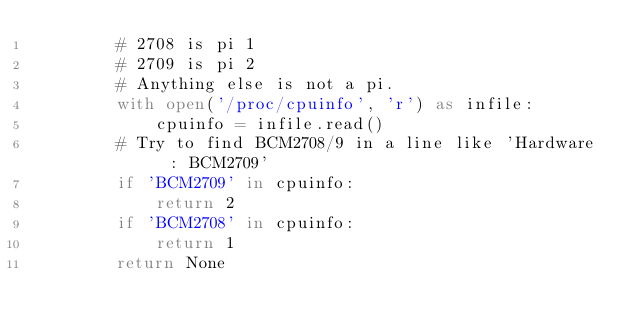<code> <loc_0><loc_0><loc_500><loc_500><_Python_>        # 2708 is pi 1
        # 2709 is pi 2
        # Anything else is not a pi.
        with open('/proc/cpuinfo', 'r') as infile:
            cpuinfo = infile.read()
        # Try to find BCM2708/9 in a line like 'Hardware   : BCM2709'
        if 'BCM2709' in cpuinfo:
            return 2
        if 'BCM2708' in cpuinfo:
            return 1
        return None 
        </code> 